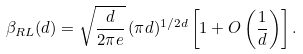<formula> <loc_0><loc_0><loc_500><loc_500>\beta _ { R L } ( d ) = \sqrt { \frac { d } { 2 \pi e } } \, ( \pi d ) ^ { 1 / 2 d } \left [ 1 + O \left ( \frac { 1 } { d } \right ) \right ] .</formula> 